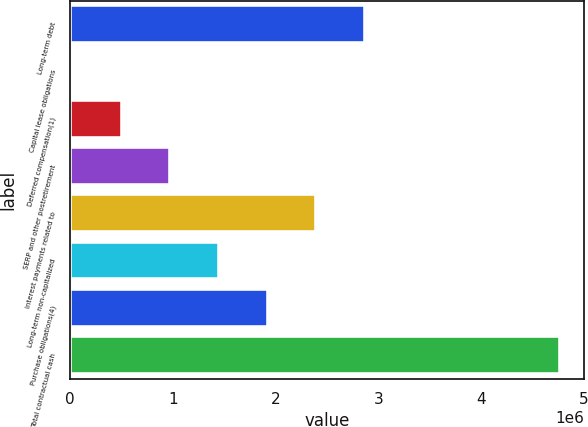Convert chart. <chart><loc_0><loc_0><loc_500><loc_500><bar_chart><fcel>Long-term debt<fcel>Capital lease obligations<fcel>Deferred compensation(1)<fcel>SERP and other postretirement<fcel>Interest payments related to<fcel>Long-term non-capitalized<fcel>Purchase obligations(4)<fcel>Total contractual cash<nl><fcel>2.87045e+06<fcel>28409<fcel>502082<fcel>975755<fcel>2.39677e+06<fcel>1.44943e+06<fcel>1.9231e+06<fcel>4.76514e+06<nl></chart> 